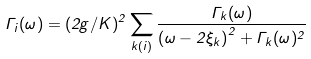Convert formula to latex. <formula><loc_0><loc_0><loc_500><loc_500>\Gamma _ { i } ( \omega ) = ( 2 g / K ) ^ { 2 } \sum _ { k ( i ) } \frac { \Gamma _ { k } ( \omega ) } { \left ( \omega - 2 \xi _ { k } \right ) ^ { 2 } + \Gamma _ { k } ( \omega ) ^ { 2 } }</formula> 